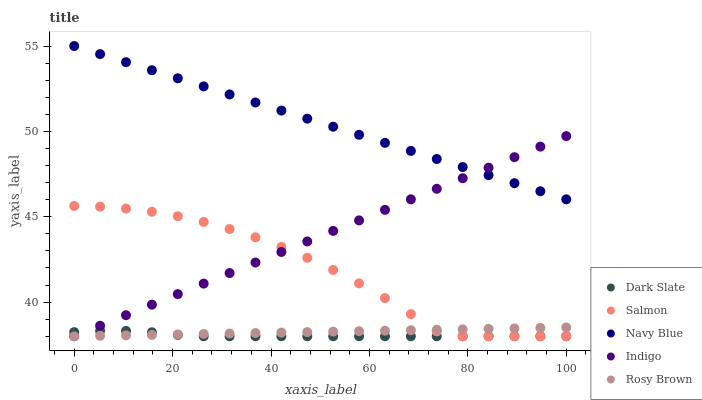Does Dark Slate have the minimum area under the curve?
Answer yes or no. Yes. Does Navy Blue have the maximum area under the curve?
Answer yes or no. Yes. Does Rosy Brown have the minimum area under the curve?
Answer yes or no. No. Does Rosy Brown have the maximum area under the curve?
Answer yes or no. No. Is Rosy Brown the smoothest?
Answer yes or no. Yes. Is Salmon the roughest?
Answer yes or no. Yes. Is Salmon the smoothest?
Answer yes or no. No. Is Rosy Brown the roughest?
Answer yes or no. No. Does Dark Slate have the lowest value?
Answer yes or no. Yes. Does Navy Blue have the lowest value?
Answer yes or no. No. Does Navy Blue have the highest value?
Answer yes or no. Yes. Does Rosy Brown have the highest value?
Answer yes or no. No. Is Salmon less than Navy Blue?
Answer yes or no. Yes. Is Navy Blue greater than Rosy Brown?
Answer yes or no. Yes. Does Dark Slate intersect Salmon?
Answer yes or no. Yes. Is Dark Slate less than Salmon?
Answer yes or no. No. Is Dark Slate greater than Salmon?
Answer yes or no. No. Does Salmon intersect Navy Blue?
Answer yes or no. No. 